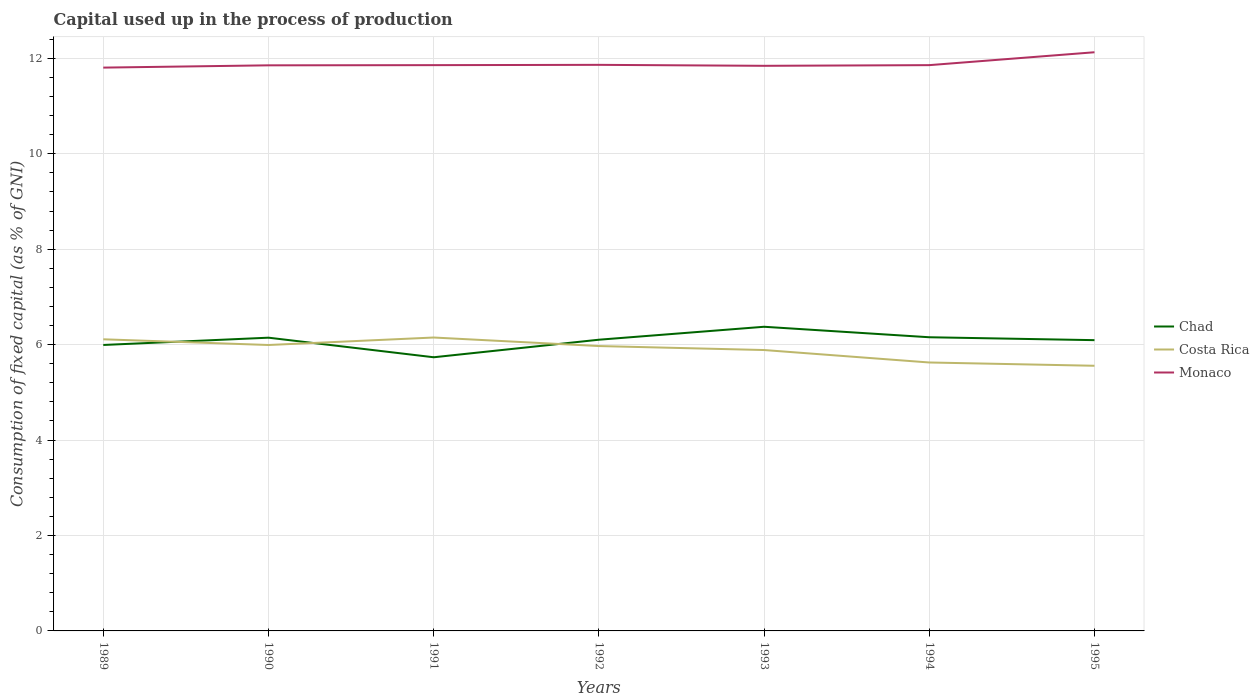Is the number of lines equal to the number of legend labels?
Provide a short and direct response. Yes. Across all years, what is the maximum capital used up in the process of production in Chad?
Keep it short and to the point. 5.74. In which year was the capital used up in the process of production in Chad maximum?
Your answer should be very brief. 1991. What is the total capital used up in the process of production in Chad in the graph?
Ensure brevity in your answer.  -0.37. What is the difference between the highest and the second highest capital used up in the process of production in Costa Rica?
Your response must be concise. 0.59. How many lines are there?
Offer a very short reply. 3. How many legend labels are there?
Provide a succinct answer. 3. How are the legend labels stacked?
Offer a terse response. Vertical. What is the title of the graph?
Offer a very short reply. Capital used up in the process of production. Does "American Samoa" appear as one of the legend labels in the graph?
Your answer should be compact. No. What is the label or title of the Y-axis?
Your answer should be very brief. Consumption of fixed capital (as % of GNI). What is the Consumption of fixed capital (as % of GNI) of Chad in 1989?
Give a very brief answer. 5.99. What is the Consumption of fixed capital (as % of GNI) of Costa Rica in 1989?
Give a very brief answer. 6.11. What is the Consumption of fixed capital (as % of GNI) of Monaco in 1989?
Your answer should be compact. 11.81. What is the Consumption of fixed capital (as % of GNI) of Chad in 1990?
Provide a short and direct response. 6.15. What is the Consumption of fixed capital (as % of GNI) of Costa Rica in 1990?
Provide a short and direct response. 5.99. What is the Consumption of fixed capital (as % of GNI) in Monaco in 1990?
Your response must be concise. 11.85. What is the Consumption of fixed capital (as % of GNI) of Chad in 1991?
Your answer should be compact. 5.74. What is the Consumption of fixed capital (as % of GNI) of Costa Rica in 1991?
Provide a succinct answer. 6.15. What is the Consumption of fixed capital (as % of GNI) in Monaco in 1991?
Offer a terse response. 11.86. What is the Consumption of fixed capital (as % of GNI) of Chad in 1992?
Provide a short and direct response. 6.1. What is the Consumption of fixed capital (as % of GNI) of Costa Rica in 1992?
Make the answer very short. 5.97. What is the Consumption of fixed capital (as % of GNI) of Monaco in 1992?
Provide a short and direct response. 11.86. What is the Consumption of fixed capital (as % of GNI) of Chad in 1993?
Provide a succinct answer. 6.37. What is the Consumption of fixed capital (as % of GNI) in Costa Rica in 1993?
Give a very brief answer. 5.89. What is the Consumption of fixed capital (as % of GNI) of Monaco in 1993?
Your response must be concise. 11.84. What is the Consumption of fixed capital (as % of GNI) of Chad in 1994?
Your answer should be compact. 6.15. What is the Consumption of fixed capital (as % of GNI) of Costa Rica in 1994?
Offer a very short reply. 5.63. What is the Consumption of fixed capital (as % of GNI) in Monaco in 1994?
Offer a very short reply. 11.86. What is the Consumption of fixed capital (as % of GNI) of Chad in 1995?
Keep it short and to the point. 6.09. What is the Consumption of fixed capital (as % of GNI) in Costa Rica in 1995?
Provide a short and direct response. 5.56. What is the Consumption of fixed capital (as % of GNI) in Monaco in 1995?
Provide a succinct answer. 12.13. Across all years, what is the maximum Consumption of fixed capital (as % of GNI) in Chad?
Provide a short and direct response. 6.37. Across all years, what is the maximum Consumption of fixed capital (as % of GNI) in Costa Rica?
Your answer should be compact. 6.15. Across all years, what is the maximum Consumption of fixed capital (as % of GNI) in Monaco?
Keep it short and to the point. 12.13. Across all years, what is the minimum Consumption of fixed capital (as % of GNI) in Chad?
Keep it short and to the point. 5.74. Across all years, what is the minimum Consumption of fixed capital (as % of GNI) in Costa Rica?
Offer a terse response. 5.56. Across all years, what is the minimum Consumption of fixed capital (as % of GNI) in Monaco?
Your answer should be very brief. 11.81. What is the total Consumption of fixed capital (as % of GNI) in Chad in the graph?
Give a very brief answer. 42.6. What is the total Consumption of fixed capital (as % of GNI) in Costa Rica in the graph?
Offer a terse response. 41.29. What is the total Consumption of fixed capital (as % of GNI) in Monaco in the graph?
Keep it short and to the point. 83.21. What is the difference between the Consumption of fixed capital (as % of GNI) in Chad in 1989 and that in 1990?
Make the answer very short. -0.15. What is the difference between the Consumption of fixed capital (as % of GNI) of Costa Rica in 1989 and that in 1990?
Give a very brief answer. 0.12. What is the difference between the Consumption of fixed capital (as % of GNI) in Monaco in 1989 and that in 1990?
Give a very brief answer. -0.05. What is the difference between the Consumption of fixed capital (as % of GNI) of Chad in 1989 and that in 1991?
Make the answer very short. 0.26. What is the difference between the Consumption of fixed capital (as % of GNI) of Costa Rica in 1989 and that in 1991?
Your answer should be very brief. -0.04. What is the difference between the Consumption of fixed capital (as % of GNI) of Monaco in 1989 and that in 1991?
Your response must be concise. -0.05. What is the difference between the Consumption of fixed capital (as % of GNI) in Chad in 1989 and that in 1992?
Your answer should be very brief. -0.11. What is the difference between the Consumption of fixed capital (as % of GNI) of Costa Rica in 1989 and that in 1992?
Keep it short and to the point. 0.14. What is the difference between the Consumption of fixed capital (as % of GNI) of Monaco in 1989 and that in 1992?
Give a very brief answer. -0.06. What is the difference between the Consumption of fixed capital (as % of GNI) of Chad in 1989 and that in 1993?
Your response must be concise. -0.38. What is the difference between the Consumption of fixed capital (as % of GNI) of Costa Rica in 1989 and that in 1993?
Your answer should be very brief. 0.22. What is the difference between the Consumption of fixed capital (as % of GNI) in Monaco in 1989 and that in 1993?
Provide a succinct answer. -0.04. What is the difference between the Consumption of fixed capital (as % of GNI) of Chad in 1989 and that in 1994?
Offer a terse response. -0.16. What is the difference between the Consumption of fixed capital (as % of GNI) of Costa Rica in 1989 and that in 1994?
Your answer should be very brief. 0.49. What is the difference between the Consumption of fixed capital (as % of GNI) in Monaco in 1989 and that in 1994?
Offer a terse response. -0.05. What is the difference between the Consumption of fixed capital (as % of GNI) in Chad in 1989 and that in 1995?
Provide a succinct answer. -0.1. What is the difference between the Consumption of fixed capital (as % of GNI) of Costa Rica in 1989 and that in 1995?
Your answer should be compact. 0.55. What is the difference between the Consumption of fixed capital (as % of GNI) in Monaco in 1989 and that in 1995?
Offer a terse response. -0.32. What is the difference between the Consumption of fixed capital (as % of GNI) of Chad in 1990 and that in 1991?
Give a very brief answer. 0.41. What is the difference between the Consumption of fixed capital (as % of GNI) in Costa Rica in 1990 and that in 1991?
Your answer should be very brief. -0.16. What is the difference between the Consumption of fixed capital (as % of GNI) of Monaco in 1990 and that in 1991?
Provide a succinct answer. -0. What is the difference between the Consumption of fixed capital (as % of GNI) in Chad in 1990 and that in 1992?
Ensure brevity in your answer.  0.04. What is the difference between the Consumption of fixed capital (as % of GNI) in Costa Rica in 1990 and that in 1992?
Your answer should be compact. 0.02. What is the difference between the Consumption of fixed capital (as % of GNI) of Monaco in 1990 and that in 1992?
Offer a terse response. -0.01. What is the difference between the Consumption of fixed capital (as % of GNI) in Chad in 1990 and that in 1993?
Provide a succinct answer. -0.23. What is the difference between the Consumption of fixed capital (as % of GNI) of Costa Rica in 1990 and that in 1993?
Your answer should be very brief. 0.11. What is the difference between the Consumption of fixed capital (as % of GNI) in Monaco in 1990 and that in 1993?
Your answer should be compact. 0.01. What is the difference between the Consumption of fixed capital (as % of GNI) of Chad in 1990 and that in 1994?
Offer a terse response. -0.01. What is the difference between the Consumption of fixed capital (as % of GNI) of Costa Rica in 1990 and that in 1994?
Make the answer very short. 0.37. What is the difference between the Consumption of fixed capital (as % of GNI) in Monaco in 1990 and that in 1994?
Make the answer very short. -0. What is the difference between the Consumption of fixed capital (as % of GNI) of Chad in 1990 and that in 1995?
Offer a very short reply. 0.05. What is the difference between the Consumption of fixed capital (as % of GNI) of Costa Rica in 1990 and that in 1995?
Offer a terse response. 0.44. What is the difference between the Consumption of fixed capital (as % of GNI) of Monaco in 1990 and that in 1995?
Your answer should be very brief. -0.27. What is the difference between the Consumption of fixed capital (as % of GNI) in Chad in 1991 and that in 1992?
Your answer should be very brief. -0.37. What is the difference between the Consumption of fixed capital (as % of GNI) in Costa Rica in 1991 and that in 1992?
Offer a very short reply. 0.18. What is the difference between the Consumption of fixed capital (as % of GNI) of Monaco in 1991 and that in 1992?
Offer a very short reply. -0.01. What is the difference between the Consumption of fixed capital (as % of GNI) of Chad in 1991 and that in 1993?
Offer a terse response. -0.64. What is the difference between the Consumption of fixed capital (as % of GNI) in Costa Rica in 1991 and that in 1993?
Make the answer very short. 0.26. What is the difference between the Consumption of fixed capital (as % of GNI) in Monaco in 1991 and that in 1993?
Offer a very short reply. 0.01. What is the difference between the Consumption of fixed capital (as % of GNI) of Chad in 1991 and that in 1994?
Your answer should be compact. -0.42. What is the difference between the Consumption of fixed capital (as % of GNI) in Costa Rica in 1991 and that in 1994?
Your response must be concise. 0.52. What is the difference between the Consumption of fixed capital (as % of GNI) in Monaco in 1991 and that in 1994?
Provide a succinct answer. 0. What is the difference between the Consumption of fixed capital (as % of GNI) of Chad in 1991 and that in 1995?
Give a very brief answer. -0.36. What is the difference between the Consumption of fixed capital (as % of GNI) in Costa Rica in 1991 and that in 1995?
Give a very brief answer. 0.59. What is the difference between the Consumption of fixed capital (as % of GNI) of Monaco in 1991 and that in 1995?
Offer a terse response. -0.27. What is the difference between the Consumption of fixed capital (as % of GNI) of Chad in 1992 and that in 1993?
Offer a terse response. -0.27. What is the difference between the Consumption of fixed capital (as % of GNI) of Costa Rica in 1992 and that in 1993?
Your answer should be compact. 0.08. What is the difference between the Consumption of fixed capital (as % of GNI) of Monaco in 1992 and that in 1993?
Your answer should be compact. 0.02. What is the difference between the Consumption of fixed capital (as % of GNI) in Chad in 1992 and that in 1994?
Offer a terse response. -0.05. What is the difference between the Consumption of fixed capital (as % of GNI) of Costa Rica in 1992 and that in 1994?
Provide a short and direct response. 0.34. What is the difference between the Consumption of fixed capital (as % of GNI) of Monaco in 1992 and that in 1994?
Make the answer very short. 0.01. What is the difference between the Consumption of fixed capital (as % of GNI) of Chad in 1992 and that in 1995?
Give a very brief answer. 0.01. What is the difference between the Consumption of fixed capital (as % of GNI) of Costa Rica in 1992 and that in 1995?
Keep it short and to the point. 0.41. What is the difference between the Consumption of fixed capital (as % of GNI) in Monaco in 1992 and that in 1995?
Your answer should be compact. -0.26. What is the difference between the Consumption of fixed capital (as % of GNI) in Chad in 1993 and that in 1994?
Provide a short and direct response. 0.22. What is the difference between the Consumption of fixed capital (as % of GNI) of Costa Rica in 1993 and that in 1994?
Provide a short and direct response. 0.26. What is the difference between the Consumption of fixed capital (as % of GNI) in Monaco in 1993 and that in 1994?
Offer a very short reply. -0.01. What is the difference between the Consumption of fixed capital (as % of GNI) of Chad in 1993 and that in 1995?
Keep it short and to the point. 0.28. What is the difference between the Consumption of fixed capital (as % of GNI) in Costa Rica in 1993 and that in 1995?
Provide a succinct answer. 0.33. What is the difference between the Consumption of fixed capital (as % of GNI) in Monaco in 1993 and that in 1995?
Your answer should be very brief. -0.28. What is the difference between the Consumption of fixed capital (as % of GNI) in Chad in 1994 and that in 1995?
Your answer should be compact. 0.06. What is the difference between the Consumption of fixed capital (as % of GNI) in Costa Rica in 1994 and that in 1995?
Keep it short and to the point. 0.07. What is the difference between the Consumption of fixed capital (as % of GNI) of Monaco in 1994 and that in 1995?
Your answer should be compact. -0.27. What is the difference between the Consumption of fixed capital (as % of GNI) of Chad in 1989 and the Consumption of fixed capital (as % of GNI) of Costa Rica in 1990?
Your response must be concise. 0. What is the difference between the Consumption of fixed capital (as % of GNI) in Chad in 1989 and the Consumption of fixed capital (as % of GNI) in Monaco in 1990?
Offer a terse response. -5.86. What is the difference between the Consumption of fixed capital (as % of GNI) in Costa Rica in 1989 and the Consumption of fixed capital (as % of GNI) in Monaco in 1990?
Provide a succinct answer. -5.74. What is the difference between the Consumption of fixed capital (as % of GNI) of Chad in 1989 and the Consumption of fixed capital (as % of GNI) of Costa Rica in 1991?
Your answer should be very brief. -0.16. What is the difference between the Consumption of fixed capital (as % of GNI) in Chad in 1989 and the Consumption of fixed capital (as % of GNI) in Monaco in 1991?
Make the answer very short. -5.86. What is the difference between the Consumption of fixed capital (as % of GNI) in Costa Rica in 1989 and the Consumption of fixed capital (as % of GNI) in Monaco in 1991?
Provide a short and direct response. -5.75. What is the difference between the Consumption of fixed capital (as % of GNI) in Chad in 1989 and the Consumption of fixed capital (as % of GNI) in Costa Rica in 1992?
Provide a succinct answer. 0.02. What is the difference between the Consumption of fixed capital (as % of GNI) in Chad in 1989 and the Consumption of fixed capital (as % of GNI) in Monaco in 1992?
Your response must be concise. -5.87. What is the difference between the Consumption of fixed capital (as % of GNI) in Costa Rica in 1989 and the Consumption of fixed capital (as % of GNI) in Monaco in 1992?
Offer a very short reply. -5.75. What is the difference between the Consumption of fixed capital (as % of GNI) of Chad in 1989 and the Consumption of fixed capital (as % of GNI) of Costa Rica in 1993?
Your answer should be compact. 0.11. What is the difference between the Consumption of fixed capital (as % of GNI) in Chad in 1989 and the Consumption of fixed capital (as % of GNI) in Monaco in 1993?
Provide a succinct answer. -5.85. What is the difference between the Consumption of fixed capital (as % of GNI) in Costa Rica in 1989 and the Consumption of fixed capital (as % of GNI) in Monaco in 1993?
Your answer should be compact. -5.73. What is the difference between the Consumption of fixed capital (as % of GNI) in Chad in 1989 and the Consumption of fixed capital (as % of GNI) in Costa Rica in 1994?
Offer a very short reply. 0.37. What is the difference between the Consumption of fixed capital (as % of GNI) in Chad in 1989 and the Consumption of fixed capital (as % of GNI) in Monaco in 1994?
Offer a terse response. -5.86. What is the difference between the Consumption of fixed capital (as % of GNI) in Costa Rica in 1989 and the Consumption of fixed capital (as % of GNI) in Monaco in 1994?
Your answer should be compact. -5.75. What is the difference between the Consumption of fixed capital (as % of GNI) in Chad in 1989 and the Consumption of fixed capital (as % of GNI) in Costa Rica in 1995?
Ensure brevity in your answer.  0.44. What is the difference between the Consumption of fixed capital (as % of GNI) in Chad in 1989 and the Consumption of fixed capital (as % of GNI) in Monaco in 1995?
Give a very brief answer. -6.13. What is the difference between the Consumption of fixed capital (as % of GNI) of Costa Rica in 1989 and the Consumption of fixed capital (as % of GNI) of Monaco in 1995?
Make the answer very short. -6.02. What is the difference between the Consumption of fixed capital (as % of GNI) of Chad in 1990 and the Consumption of fixed capital (as % of GNI) of Costa Rica in 1991?
Your answer should be compact. -0. What is the difference between the Consumption of fixed capital (as % of GNI) of Chad in 1990 and the Consumption of fixed capital (as % of GNI) of Monaco in 1991?
Keep it short and to the point. -5.71. What is the difference between the Consumption of fixed capital (as % of GNI) in Costa Rica in 1990 and the Consumption of fixed capital (as % of GNI) in Monaco in 1991?
Make the answer very short. -5.87. What is the difference between the Consumption of fixed capital (as % of GNI) in Chad in 1990 and the Consumption of fixed capital (as % of GNI) in Costa Rica in 1992?
Provide a succinct answer. 0.18. What is the difference between the Consumption of fixed capital (as % of GNI) in Chad in 1990 and the Consumption of fixed capital (as % of GNI) in Monaco in 1992?
Make the answer very short. -5.72. What is the difference between the Consumption of fixed capital (as % of GNI) of Costa Rica in 1990 and the Consumption of fixed capital (as % of GNI) of Monaco in 1992?
Your response must be concise. -5.87. What is the difference between the Consumption of fixed capital (as % of GNI) in Chad in 1990 and the Consumption of fixed capital (as % of GNI) in Costa Rica in 1993?
Offer a very short reply. 0.26. What is the difference between the Consumption of fixed capital (as % of GNI) of Chad in 1990 and the Consumption of fixed capital (as % of GNI) of Monaco in 1993?
Your response must be concise. -5.7. What is the difference between the Consumption of fixed capital (as % of GNI) of Costa Rica in 1990 and the Consumption of fixed capital (as % of GNI) of Monaco in 1993?
Your answer should be compact. -5.85. What is the difference between the Consumption of fixed capital (as % of GNI) of Chad in 1990 and the Consumption of fixed capital (as % of GNI) of Costa Rica in 1994?
Provide a short and direct response. 0.52. What is the difference between the Consumption of fixed capital (as % of GNI) of Chad in 1990 and the Consumption of fixed capital (as % of GNI) of Monaco in 1994?
Give a very brief answer. -5.71. What is the difference between the Consumption of fixed capital (as % of GNI) of Costa Rica in 1990 and the Consumption of fixed capital (as % of GNI) of Monaco in 1994?
Your answer should be very brief. -5.87. What is the difference between the Consumption of fixed capital (as % of GNI) of Chad in 1990 and the Consumption of fixed capital (as % of GNI) of Costa Rica in 1995?
Provide a succinct answer. 0.59. What is the difference between the Consumption of fixed capital (as % of GNI) of Chad in 1990 and the Consumption of fixed capital (as % of GNI) of Monaco in 1995?
Provide a short and direct response. -5.98. What is the difference between the Consumption of fixed capital (as % of GNI) in Costa Rica in 1990 and the Consumption of fixed capital (as % of GNI) in Monaco in 1995?
Ensure brevity in your answer.  -6.14. What is the difference between the Consumption of fixed capital (as % of GNI) of Chad in 1991 and the Consumption of fixed capital (as % of GNI) of Costa Rica in 1992?
Keep it short and to the point. -0.23. What is the difference between the Consumption of fixed capital (as % of GNI) in Chad in 1991 and the Consumption of fixed capital (as % of GNI) in Monaco in 1992?
Provide a succinct answer. -6.13. What is the difference between the Consumption of fixed capital (as % of GNI) of Costa Rica in 1991 and the Consumption of fixed capital (as % of GNI) of Monaco in 1992?
Your response must be concise. -5.71. What is the difference between the Consumption of fixed capital (as % of GNI) in Chad in 1991 and the Consumption of fixed capital (as % of GNI) in Costa Rica in 1993?
Offer a very short reply. -0.15. What is the difference between the Consumption of fixed capital (as % of GNI) in Chad in 1991 and the Consumption of fixed capital (as % of GNI) in Monaco in 1993?
Your response must be concise. -6.11. What is the difference between the Consumption of fixed capital (as % of GNI) of Costa Rica in 1991 and the Consumption of fixed capital (as % of GNI) of Monaco in 1993?
Offer a very short reply. -5.69. What is the difference between the Consumption of fixed capital (as % of GNI) of Chad in 1991 and the Consumption of fixed capital (as % of GNI) of Costa Rica in 1994?
Your answer should be compact. 0.11. What is the difference between the Consumption of fixed capital (as % of GNI) in Chad in 1991 and the Consumption of fixed capital (as % of GNI) in Monaco in 1994?
Give a very brief answer. -6.12. What is the difference between the Consumption of fixed capital (as % of GNI) of Costa Rica in 1991 and the Consumption of fixed capital (as % of GNI) of Monaco in 1994?
Give a very brief answer. -5.71. What is the difference between the Consumption of fixed capital (as % of GNI) in Chad in 1991 and the Consumption of fixed capital (as % of GNI) in Costa Rica in 1995?
Offer a very short reply. 0.18. What is the difference between the Consumption of fixed capital (as % of GNI) of Chad in 1991 and the Consumption of fixed capital (as % of GNI) of Monaco in 1995?
Make the answer very short. -6.39. What is the difference between the Consumption of fixed capital (as % of GNI) of Costa Rica in 1991 and the Consumption of fixed capital (as % of GNI) of Monaco in 1995?
Provide a short and direct response. -5.98. What is the difference between the Consumption of fixed capital (as % of GNI) in Chad in 1992 and the Consumption of fixed capital (as % of GNI) in Costa Rica in 1993?
Offer a very short reply. 0.22. What is the difference between the Consumption of fixed capital (as % of GNI) of Chad in 1992 and the Consumption of fixed capital (as % of GNI) of Monaco in 1993?
Keep it short and to the point. -5.74. What is the difference between the Consumption of fixed capital (as % of GNI) in Costa Rica in 1992 and the Consumption of fixed capital (as % of GNI) in Monaco in 1993?
Make the answer very short. -5.87. What is the difference between the Consumption of fixed capital (as % of GNI) in Chad in 1992 and the Consumption of fixed capital (as % of GNI) in Costa Rica in 1994?
Your answer should be compact. 0.48. What is the difference between the Consumption of fixed capital (as % of GNI) of Chad in 1992 and the Consumption of fixed capital (as % of GNI) of Monaco in 1994?
Your answer should be compact. -5.75. What is the difference between the Consumption of fixed capital (as % of GNI) of Costa Rica in 1992 and the Consumption of fixed capital (as % of GNI) of Monaco in 1994?
Provide a succinct answer. -5.89. What is the difference between the Consumption of fixed capital (as % of GNI) in Chad in 1992 and the Consumption of fixed capital (as % of GNI) in Costa Rica in 1995?
Provide a succinct answer. 0.55. What is the difference between the Consumption of fixed capital (as % of GNI) in Chad in 1992 and the Consumption of fixed capital (as % of GNI) in Monaco in 1995?
Your response must be concise. -6.02. What is the difference between the Consumption of fixed capital (as % of GNI) of Costa Rica in 1992 and the Consumption of fixed capital (as % of GNI) of Monaco in 1995?
Make the answer very short. -6.16. What is the difference between the Consumption of fixed capital (as % of GNI) in Chad in 1993 and the Consumption of fixed capital (as % of GNI) in Costa Rica in 1994?
Ensure brevity in your answer.  0.75. What is the difference between the Consumption of fixed capital (as % of GNI) in Chad in 1993 and the Consumption of fixed capital (as % of GNI) in Monaco in 1994?
Offer a very short reply. -5.48. What is the difference between the Consumption of fixed capital (as % of GNI) in Costa Rica in 1993 and the Consumption of fixed capital (as % of GNI) in Monaco in 1994?
Give a very brief answer. -5.97. What is the difference between the Consumption of fixed capital (as % of GNI) in Chad in 1993 and the Consumption of fixed capital (as % of GNI) in Costa Rica in 1995?
Make the answer very short. 0.82. What is the difference between the Consumption of fixed capital (as % of GNI) of Chad in 1993 and the Consumption of fixed capital (as % of GNI) of Monaco in 1995?
Provide a succinct answer. -5.75. What is the difference between the Consumption of fixed capital (as % of GNI) of Costa Rica in 1993 and the Consumption of fixed capital (as % of GNI) of Monaco in 1995?
Keep it short and to the point. -6.24. What is the difference between the Consumption of fixed capital (as % of GNI) of Chad in 1994 and the Consumption of fixed capital (as % of GNI) of Costa Rica in 1995?
Provide a short and direct response. 0.6. What is the difference between the Consumption of fixed capital (as % of GNI) of Chad in 1994 and the Consumption of fixed capital (as % of GNI) of Monaco in 1995?
Your response must be concise. -5.97. What is the difference between the Consumption of fixed capital (as % of GNI) in Costa Rica in 1994 and the Consumption of fixed capital (as % of GNI) in Monaco in 1995?
Provide a succinct answer. -6.5. What is the average Consumption of fixed capital (as % of GNI) of Chad per year?
Make the answer very short. 6.09. What is the average Consumption of fixed capital (as % of GNI) of Costa Rica per year?
Provide a short and direct response. 5.9. What is the average Consumption of fixed capital (as % of GNI) in Monaco per year?
Provide a short and direct response. 11.89. In the year 1989, what is the difference between the Consumption of fixed capital (as % of GNI) in Chad and Consumption of fixed capital (as % of GNI) in Costa Rica?
Give a very brief answer. -0.12. In the year 1989, what is the difference between the Consumption of fixed capital (as % of GNI) of Chad and Consumption of fixed capital (as % of GNI) of Monaco?
Ensure brevity in your answer.  -5.81. In the year 1989, what is the difference between the Consumption of fixed capital (as % of GNI) in Costa Rica and Consumption of fixed capital (as % of GNI) in Monaco?
Your answer should be very brief. -5.69. In the year 1990, what is the difference between the Consumption of fixed capital (as % of GNI) of Chad and Consumption of fixed capital (as % of GNI) of Costa Rica?
Offer a terse response. 0.15. In the year 1990, what is the difference between the Consumption of fixed capital (as % of GNI) of Chad and Consumption of fixed capital (as % of GNI) of Monaco?
Provide a succinct answer. -5.71. In the year 1990, what is the difference between the Consumption of fixed capital (as % of GNI) of Costa Rica and Consumption of fixed capital (as % of GNI) of Monaco?
Provide a short and direct response. -5.86. In the year 1991, what is the difference between the Consumption of fixed capital (as % of GNI) of Chad and Consumption of fixed capital (as % of GNI) of Costa Rica?
Your response must be concise. -0.41. In the year 1991, what is the difference between the Consumption of fixed capital (as % of GNI) of Chad and Consumption of fixed capital (as % of GNI) of Monaco?
Give a very brief answer. -6.12. In the year 1991, what is the difference between the Consumption of fixed capital (as % of GNI) in Costa Rica and Consumption of fixed capital (as % of GNI) in Monaco?
Offer a very short reply. -5.71. In the year 1992, what is the difference between the Consumption of fixed capital (as % of GNI) in Chad and Consumption of fixed capital (as % of GNI) in Costa Rica?
Keep it short and to the point. 0.13. In the year 1992, what is the difference between the Consumption of fixed capital (as % of GNI) in Chad and Consumption of fixed capital (as % of GNI) in Monaco?
Your answer should be compact. -5.76. In the year 1992, what is the difference between the Consumption of fixed capital (as % of GNI) of Costa Rica and Consumption of fixed capital (as % of GNI) of Monaco?
Provide a short and direct response. -5.89. In the year 1993, what is the difference between the Consumption of fixed capital (as % of GNI) of Chad and Consumption of fixed capital (as % of GNI) of Costa Rica?
Your answer should be very brief. 0.49. In the year 1993, what is the difference between the Consumption of fixed capital (as % of GNI) of Chad and Consumption of fixed capital (as % of GNI) of Monaco?
Your response must be concise. -5.47. In the year 1993, what is the difference between the Consumption of fixed capital (as % of GNI) of Costa Rica and Consumption of fixed capital (as % of GNI) of Monaco?
Offer a very short reply. -5.96. In the year 1994, what is the difference between the Consumption of fixed capital (as % of GNI) of Chad and Consumption of fixed capital (as % of GNI) of Costa Rica?
Provide a short and direct response. 0.53. In the year 1994, what is the difference between the Consumption of fixed capital (as % of GNI) in Chad and Consumption of fixed capital (as % of GNI) in Monaco?
Provide a short and direct response. -5.7. In the year 1994, what is the difference between the Consumption of fixed capital (as % of GNI) of Costa Rica and Consumption of fixed capital (as % of GNI) of Monaco?
Ensure brevity in your answer.  -6.23. In the year 1995, what is the difference between the Consumption of fixed capital (as % of GNI) in Chad and Consumption of fixed capital (as % of GNI) in Costa Rica?
Provide a short and direct response. 0.54. In the year 1995, what is the difference between the Consumption of fixed capital (as % of GNI) of Chad and Consumption of fixed capital (as % of GNI) of Monaco?
Your response must be concise. -6.03. In the year 1995, what is the difference between the Consumption of fixed capital (as % of GNI) in Costa Rica and Consumption of fixed capital (as % of GNI) in Monaco?
Offer a terse response. -6.57. What is the ratio of the Consumption of fixed capital (as % of GNI) in Chad in 1989 to that in 1990?
Provide a short and direct response. 0.98. What is the ratio of the Consumption of fixed capital (as % of GNI) in Costa Rica in 1989 to that in 1990?
Your answer should be very brief. 1.02. What is the ratio of the Consumption of fixed capital (as % of GNI) of Monaco in 1989 to that in 1990?
Provide a short and direct response. 1. What is the ratio of the Consumption of fixed capital (as % of GNI) in Chad in 1989 to that in 1991?
Keep it short and to the point. 1.04. What is the ratio of the Consumption of fixed capital (as % of GNI) of Costa Rica in 1989 to that in 1992?
Your answer should be compact. 1.02. What is the ratio of the Consumption of fixed capital (as % of GNI) in Chad in 1989 to that in 1993?
Give a very brief answer. 0.94. What is the ratio of the Consumption of fixed capital (as % of GNI) in Costa Rica in 1989 to that in 1993?
Give a very brief answer. 1.04. What is the ratio of the Consumption of fixed capital (as % of GNI) of Chad in 1989 to that in 1994?
Offer a very short reply. 0.97. What is the ratio of the Consumption of fixed capital (as % of GNI) of Costa Rica in 1989 to that in 1994?
Keep it short and to the point. 1.09. What is the ratio of the Consumption of fixed capital (as % of GNI) of Monaco in 1989 to that in 1994?
Your answer should be very brief. 1. What is the ratio of the Consumption of fixed capital (as % of GNI) in Chad in 1989 to that in 1995?
Offer a terse response. 0.98. What is the ratio of the Consumption of fixed capital (as % of GNI) in Costa Rica in 1989 to that in 1995?
Your response must be concise. 1.1. What is the ratio of the Consumption of fixed capital (as % of GNI) in Monaco in 1989 to that in 1995?
Provide a short and direct response. 0.97. What is the ratio of the Consumption of fixed capital (as % of GNI) in Chad in 1990 to that in 1991?
Offer a very short reply. 1.07. What is the ratio of the Consumption of fixed capital (as % of GNI) of Costa Rica in 1990 to that in 1991?
Provide a short and direct response. 0.97. What is the ratio of the Consumption of fixed capital (as % of GNI) of Chad in 1990 to that in 1992?
Give a very brief answer. 1.01. What is the ratio of the Consumption of fixed capital (as % of GNI) in Monaco in 1990 to that in 1992?
Ensure brevity in your answer.  1. What is the ratio of the Consumption of fixed capital (as % of GNI) of Chad in 1990 to that in 1993?
Make the answer very short. 0.96. What is the ratio of the Consumption of fixed capital (as % of GNI) in Costa Rica in 1990 to that in 1993?
Provide a succinct answer. 1.02. What is the ratio of the Consumption of fixed capital (as % of GNI) in Costa Rica in 1990 to that in 1994?
Ensure brevity in your answer.  1.07. What is the ratio of the Consumption of fixed capital (as % of GNI) of Chad in 1990 to that in 1995?
Provide a succinct answer. 1.01. What is the ratio of the Consumption of fixed capital (as % of GNI) in Costa Rica in 1990 to that in 1995?
Provide a short and direct response. 1.08. What is the ratio of the Consumption of fixed capital (as % of GNI) of Monaco in 1990 to that in 1995?
Offer a terse response. 0.98. What is the ratio of the Consumption of fixed capital (as % of GNI) in Chad in 1991 to that in 1992?
Offer a very short reply. 0.94. What is the ratio of the Consumption of fixed capital (as % of GNI) in Costa Rica in 1991 to that in 1992?
Keep it short and to the point. 1.03. What is the ratio of the Consumption of fixed capital (as % of GNI) in Monaco in 1991 to that in 1992?
Provide a short and direct response. 1. What is the ratio of the Consumption of fixed capital (as % of GNI) in Chad in 1991 to that in 1993?
Offer a very short reply. 0.9. What is the ratio of the Consumption of fixed capital (as % of GNI) in Costa Rica in 1991 to that in 1993?
Your answer should be compact. 1.04. What is the ratio of the Consumption of fixed capital (as % of GNI) of Monaco in 1991 to that in 1993?
Provide a short and direct response. 1. What is the ratio of the Consumption of fixed capital (as % of GNI) in Chad in 1991 to that in 1994?
Make the answer very short. 0.93. What is the ratio of the Consumption of fixed capital (as % of GNI) in Costa Rica in 1991 to that in 1994?
Provide a succinct answer. 1.09. What is the ratio of the Consumption of fixed capital (as % of GNI) of Monaco in 1991 to that in 1994?
Give a very brief answer. 1. What is the ratio of the Consumption of fixed capital (as % of GNI) of Chad in 1991 to that in 1995?
Offer a very short reply. 0.94. What is the ratio of the Consumption of fixed capital (as % of GNI) of Costa Rica in 1991 to that in 1995?
Offer a terse response. 1.11. What is the ratio of the Consumption of fixed capital (as % of GNI) of Monaco in 1991 to that in 1995?
Ensure brevity in your answer.  0.98. What is the ratio of the Consumption of fixed capital (as % of GNI) of Chad in 1992 to that in 1993?
Offer a very short reply. 0.96. What is the ratio of the Consumption of fixed capital (as % of GNI) in Costa Rica in 1992 to that in 1993?
Offer a terse response. 1.01. What is the ratio of the Consumption of fixed capital (as % of GNI) of Costa Rica in 1992 to that in 1994?
Keep it short and to the point. 1.06. What is the ratio of the Consumption of fixed capital (as % of GNI) of Costa Rica in 1992 to that in 1995?
Provide a succinct answer. 1.07. What is the ratio of the Consumption of fixed capital (as % of GNI) of Monaco in 1992 to that in 1995?
Your answer should be compact. 0.98. What is the ratio of the Consumption of fixed capital (as % of GNI) of Chad in 1993 to that in 1994?
Give a very brief answer. 1.04. What is the ratio of the Consumption of fixed capital (as % of GNI) in Costa Rica in 1993 to that in 1994?
Your answer should be very brief. 1.05. What is the ratio of the Consumption of fixed capital (as % of GNI) of Chad in 1993 to that in 1995?
Offer a terse response. 1.05. What is the ratio of the Consumption of fixed capital (as % of GNI) in Costa Rica in 1993 to that in 1995?
Keep it short and to the point. 1.06. What is the ratio of the Consumption of fixed capital (as % of GNI) in Monaco in 1993 to that in 1995?
Your response must be concise. 0.98. What is the ratio of the Consumption of fixed capital (as % of GNI) of Costa Rica in 1994 to that in 1995?
Offer a very short reply. 1.01. What is the ratio of the Consumption of fixed capital (as % of GNI) of Monaco in 1994 to that in 1995?
Offer a very short reply. 0.98. What is the difference between the highest and the second highest Consumption of fixed capital (as % of GNI) of Chad?
Offer a very short reply. 0.22. What is the difference between the highest and the second highest Consumption of fixed capital (as % of GNI) of Costa Rica?
Give a very brief answer. 0.04. What is the difference between the highest and the second highest Consumption of fixed capital (as % of GNI) in Monaco?
Give a very brief answer. 0.26. What is the difference between the highest and the lowest Consumption of fixed capital (as % of GNI) in Chad?
Offer a very short reply. 0.64. What is the difference between the highest and the lowest Consumption of fixed capital (as % of GNI) in Costa Rica?
Offer a terse response. 0.59. What is the difference between the highest and the lowest Consumption of fixed capital (as % of GNI) of Monaco?
Make the answer very short. 0.32. 